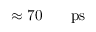<formula> <loc_0><loc_0><loc_500><loc_500>\approx 7 0 { { \, } } { p s }</formula> 